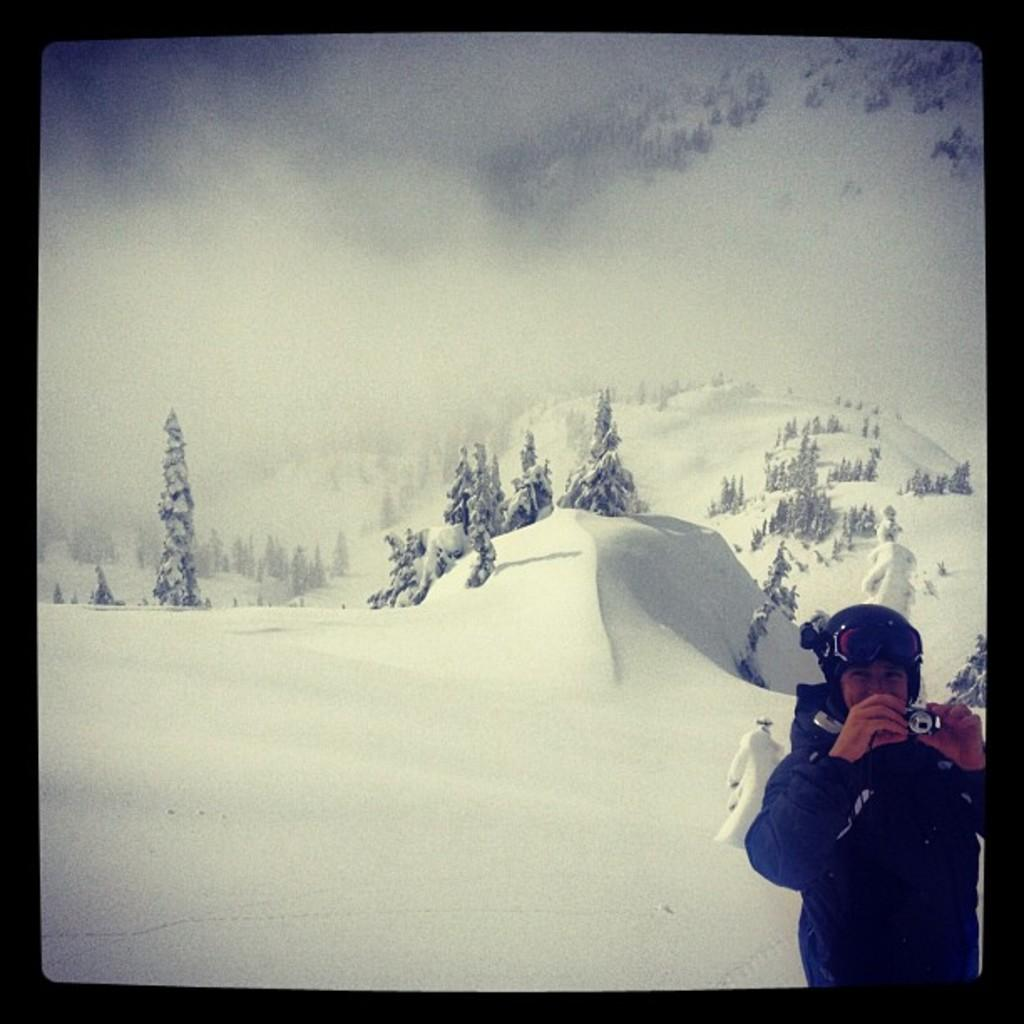What is the main subject of the image? There is a person in the image. What is the person doing in the image? The person is standing and holding a camera in their hand. What can be seen in the background of the image? There is snow, trees, and fog in the background of the image. How many apples are on the ground in the image? There are no apples present in the image. What type of jelly is being used to create the fog in the image? There is no jelly present in the image; the fog is a natural occurrence. 